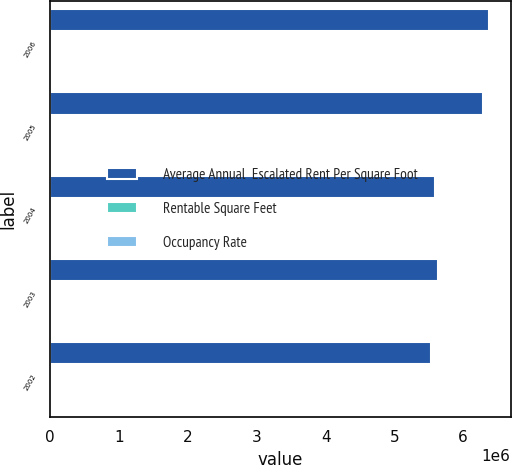Convert chart. <chart><loc_0><loc_0><loc_500><loc_500><stacked_bar_chart><ecel><fcel>2006<fcel>2005<fcel>2004<fcel>2003<fcel>2002<nl><fcel>Average Annual  Escalated Rent Per Square Foot<fcel>6.37e+06<fcel>6.29e+06<fcel>5.589e+06<fcel>5.64e+06<fcel>5.528e+06<nl><fcel>Rentable Square Feet<fcel>93.6<fcel>94.7<fcel>97.6<fcel>95.1<fcel>95.2<nl><fcel>Occupancy Rate<fcel>25.17<fcel>24.04<fcel>23.08<fcel>22.35<fcel>21.46<nl></chart> 